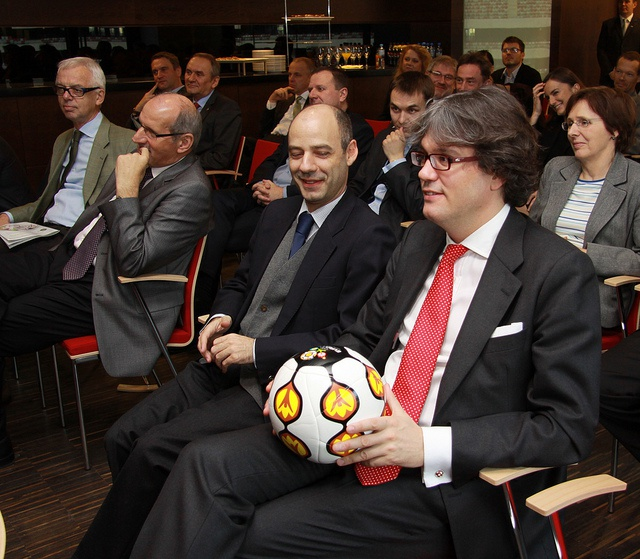Describe the objects in this image and their specific colors. I can see people in black, lightgray, maroon, and gray tones, people in black, gray, and tan tones, people in black, gray, maroon, and brown tones, people in black, gray, maroon, and lightgray tones, and sports ball in black, white, yellow, and darkgray tones in this image. 